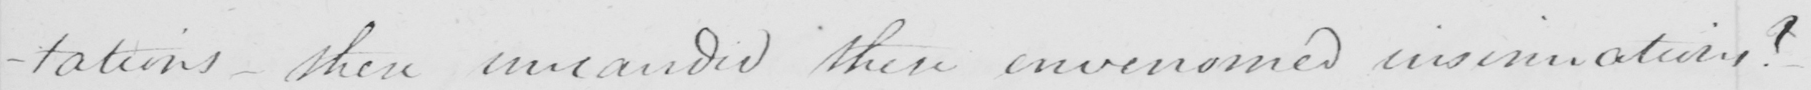What is written in this line of handwriting? -tations  _  these uncandid these envenomed insinuations ? 